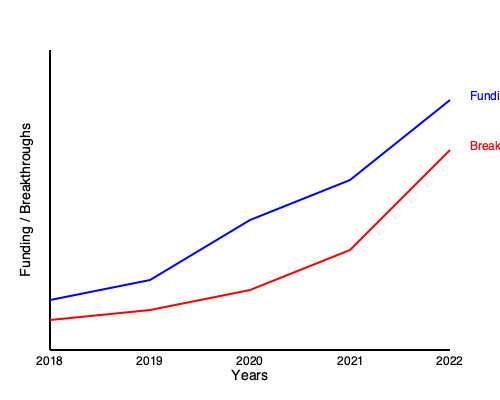Based on the trends shown in the graph, what conclusion can be drawn about the relationship between research funding and scientific breakthroughs, and how might this impact future funding decisions? To answer this question, we need to analyze the trends in the graph and their implications:

1. Funding trend (blue line):
   - Shows a steady increase from 2018 to 2022
   - The slope of the line is relatively steep, indicating significant growth in funding

2. Breakthroughs trend (red line):
   - Also shows an increase from 2018 to 2022
   - The slope is less steep compared to the funding line

3. Relationship between funding and breakthroughs:
   - Both lines show an upward trend, suggesting a positive correlation
   - However, the rate of increase in breakthroughs is slower than the rate of increase in funding

4. Efficiency analysis:
   - The gap between the funding line and the breakthroughs line widens over time
   - This suggests diminishing returns on investment, as more funding is required to achieve proportionally fewer breakthroughs

5. Impact on future funding decisions:
   - The diminishing returns might lead to questioning the efficiency of continued funding increases
   - Decision-makers might consider:
     a) Maintaining current funding levels to optimize return on investment
     b) Exploring alternative research strategies to improve the breakthroughs-to-funding ratio
     c) Implementing more stringent evaluation criteria for funded projects

6. Long-term considerations:
   - The trend might not continue indefinitely, and breakthroughs could potentially accelerate in the future
   - Some research fields may require sustained funding over long periods before yielding significant breakthroughs

Given these observations, a skeptical government official would likely conclude that while increased funding has led to more breakthroughs, the return on investment is decreasing. This could prompt a reevaluation of funding strategies to maximize efficiency and impact.
Answer: Positive correlation with diminishing returns, suggesting need for funding strategy reevaluation. 